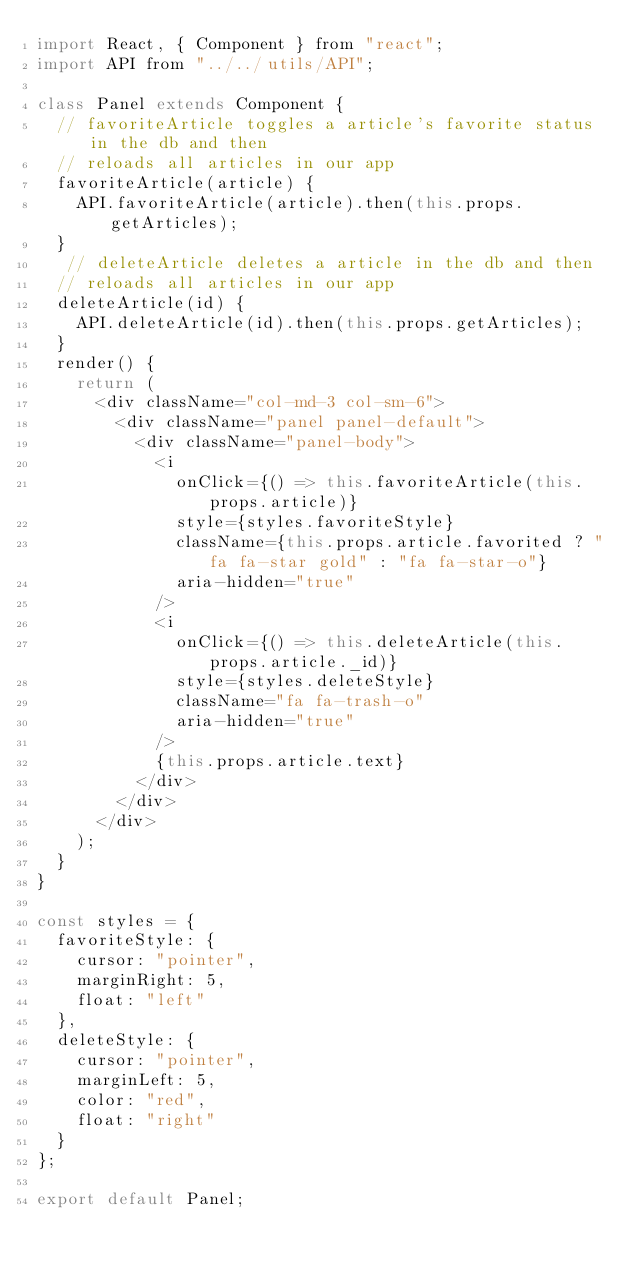Convert code to text. <code><loc_0><loc_0><loc_500><loc_500><_JavaScript_>import React, { Component } from "react";
import API from "../../utils/API";

class Panel extends Component {
  // favoriteArticle toggles a article's favorite status in the db and then
  // reloads all articles in our app
  favoriteArticle(article) {
    API.favoriteArticle(article).then(this.props.getArticles);
  }
   // deleteArticle deletes a article in the db and then
  // reloads all articles in our app
  deleteArticle(id) {
    API.deleteArticle(id).then(this.props.getArticles);
  }
  render() {
    return (
      <div className="col-md-3 col-sm-6">
        <div className="panel panel-default">
          <div className="panel-body">
            <i
              onClick={() => this.favoriteArticle(this.props.article)}
              style={styles.favoriteStyle}
              className={this.props.article.favorited ? "fa fa-star gold" : "fa fa-star-o"}
              aria-hidden="true"
            />
            <i
              onClick={() => this.deleteArticle(this.props.article._id)}
              style={styles.deleteStyle}
              className="fa fa-trash-o"
              aria-hidden="true"
            />
            {this.props.article.text}
          </div>
        </div>
      </div>
    );
  }
}

const styles = {
  favoriteStyle: {
    cursor: "pointer",
    marginRight: 5,
    float: "left"
  },
  deleteStyle: {
    cursor: "pointer",
    marginLeft: 5,
    color: "red",
    float: "right"
  }
};

export default Panel;
</code> 